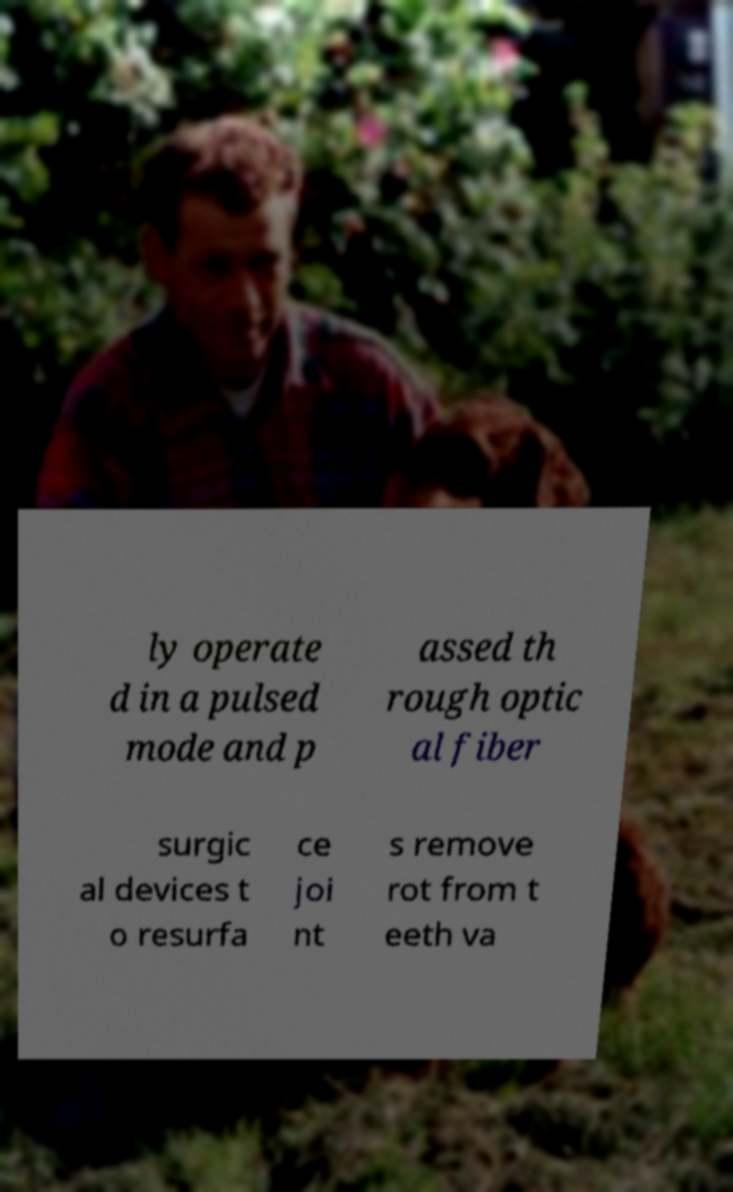Please read and relay the text visible in this image. What does it say? ly operate d in a pulsed mode and p assed th rough optic al fiber surgic al devices t o resurfa ce joi nt s remove rot from t eeth va 